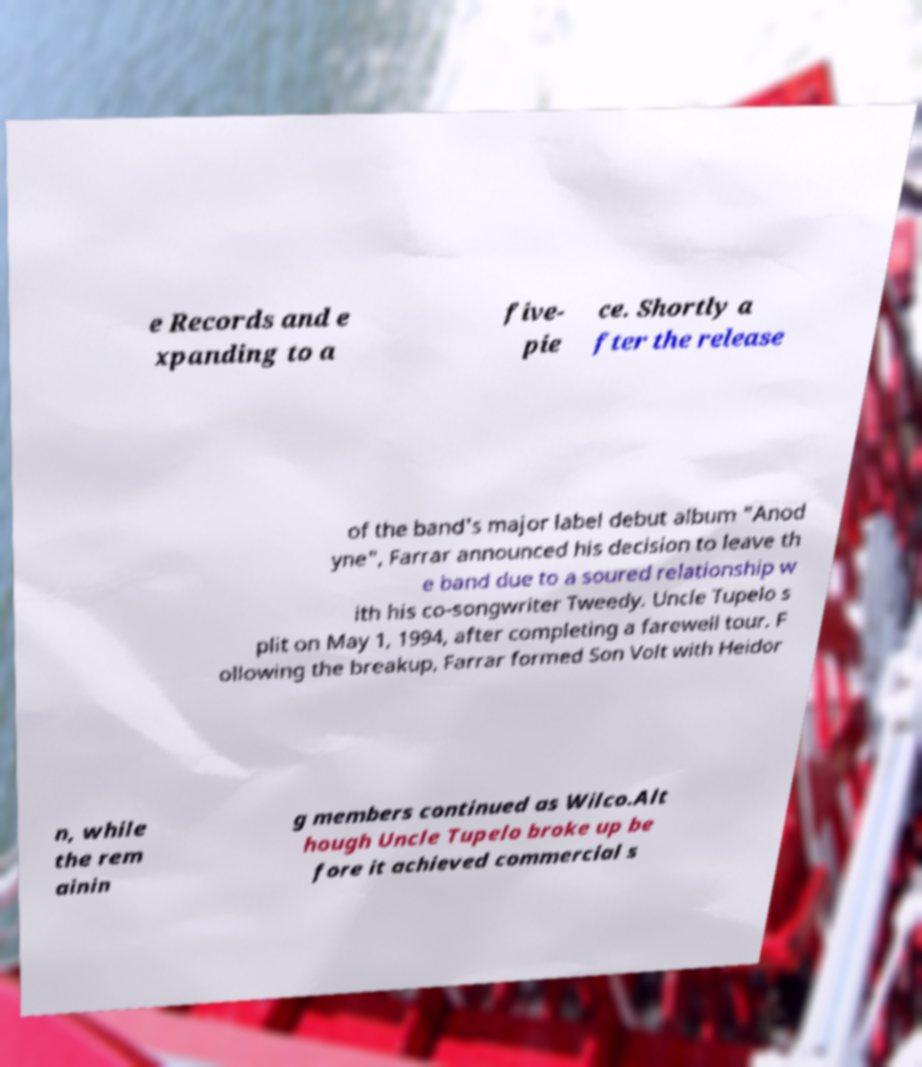Please identify and transcribe the text found in this image. e Records and e xpanding to a five- pie ce. Shortly a fter the release of the band's major label debut album "Anod yne", Farrar announced his decision to leave th e band due to a soured relationship w ith his co-songwriter Tweedy. Uncle Tupelo s plit on May 1, 1994, after completing a farewell tour. F ollowing the breakup, Farrar formed Son Volt with Heidor n, while the rem ainin g members continued as Wilco.Alt hough Uncle Tupelo broke up be fore it achieved commercial s 